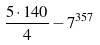Convert formula to latex. <formula><loc_0><loc_0><loc_500><loc_500>\frac { 5 \cdot 1 4 0 } { 4 } - 7 ^ { 3 5 7 }</formula> 